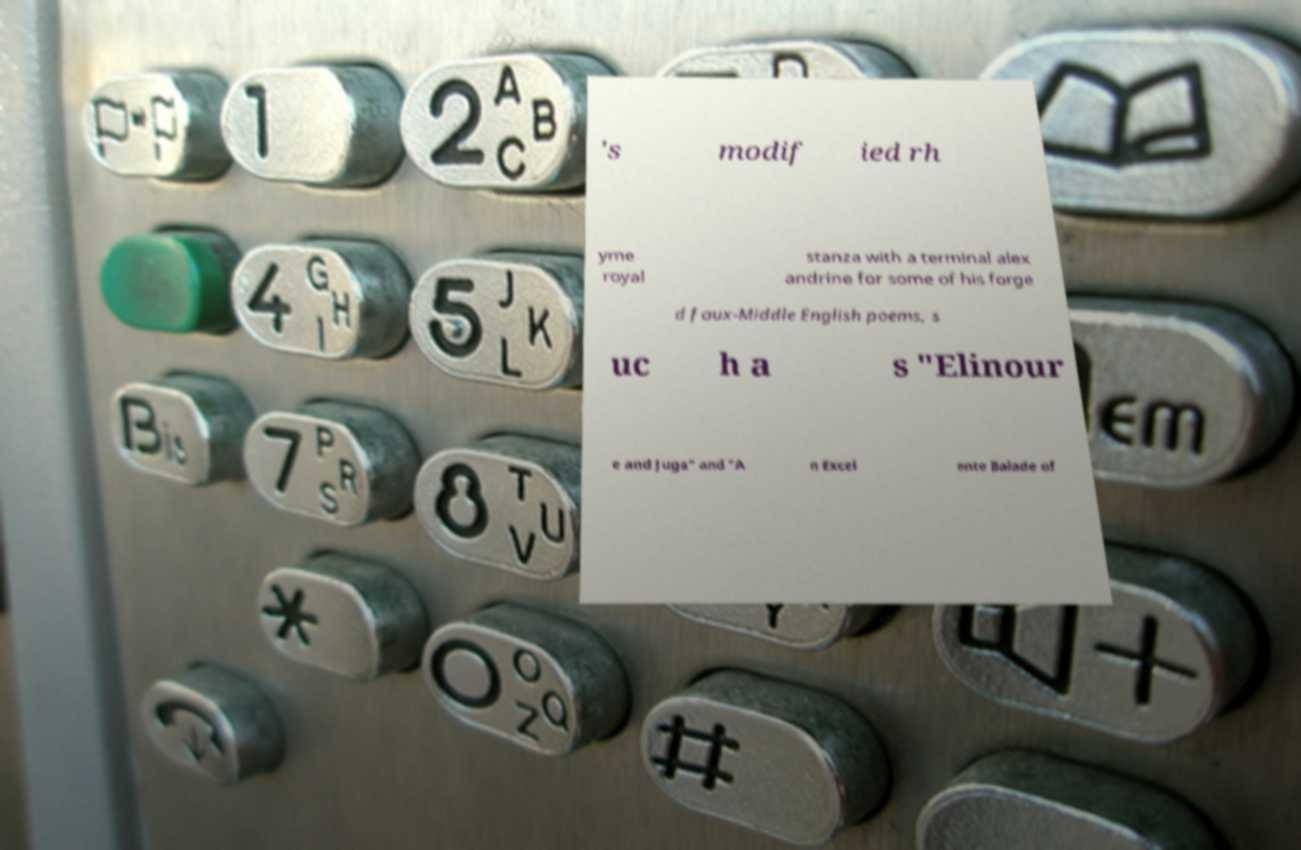There's text embedded in this image that I need extracted. Can you transcribe it verbatim? 's modif ied rh yme royal stanza with a terminal alex andrine for some of his forge d faux-Middle English poems, s uc h a s "Elinour e and Juga" and "A n Excel ente Balade of 